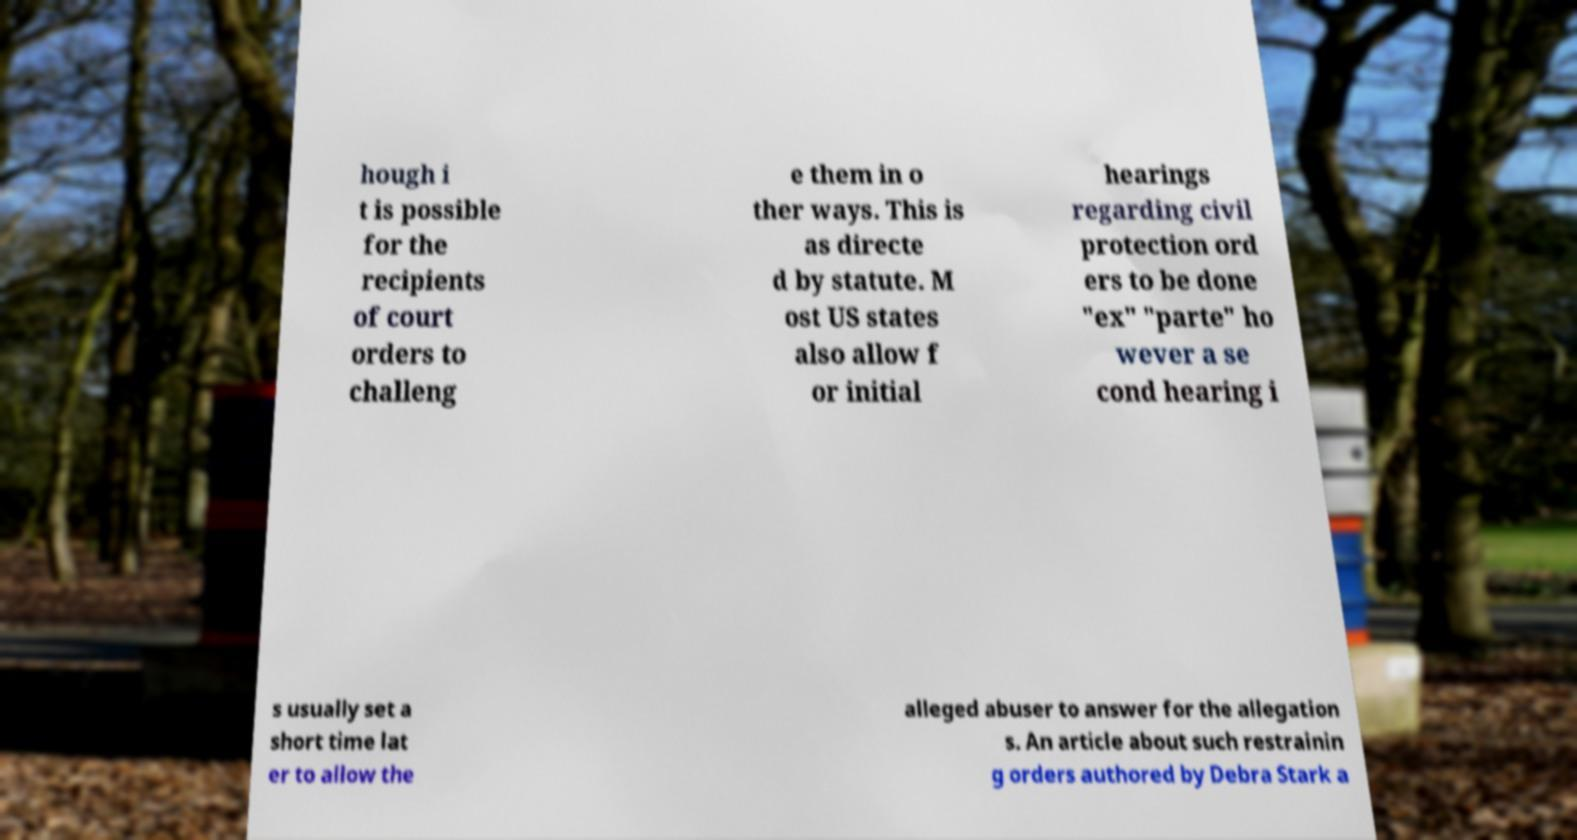Can you read and provide the text displayed in the image?This photo seems to have some interesting text. Can you extract and type it out for me? hough i t is possible for the recipients of court orders to challeng e them in o ther ways. This is as directe d by statute. M ost US states also allow f or initial hearings regarding civil protection ord ers to be done "ex" "parte" ho wever a se cond hearing i s usually set a short time lat er to allow the alleged abuser to answer for the allegation s. An article about such restrainin g orders authored by Debra Stark a 